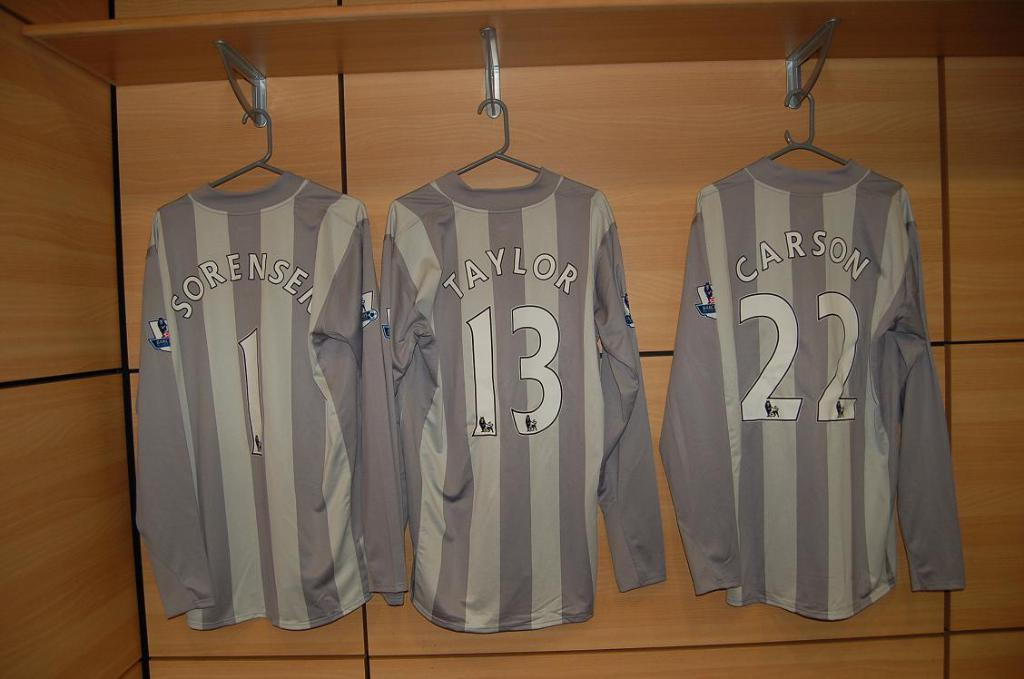<image>
Offer a succinct explanation of the picture presented. Three sports uniforms hung on hangers, with the number and last names; Taylor, Carson and Sorensen 